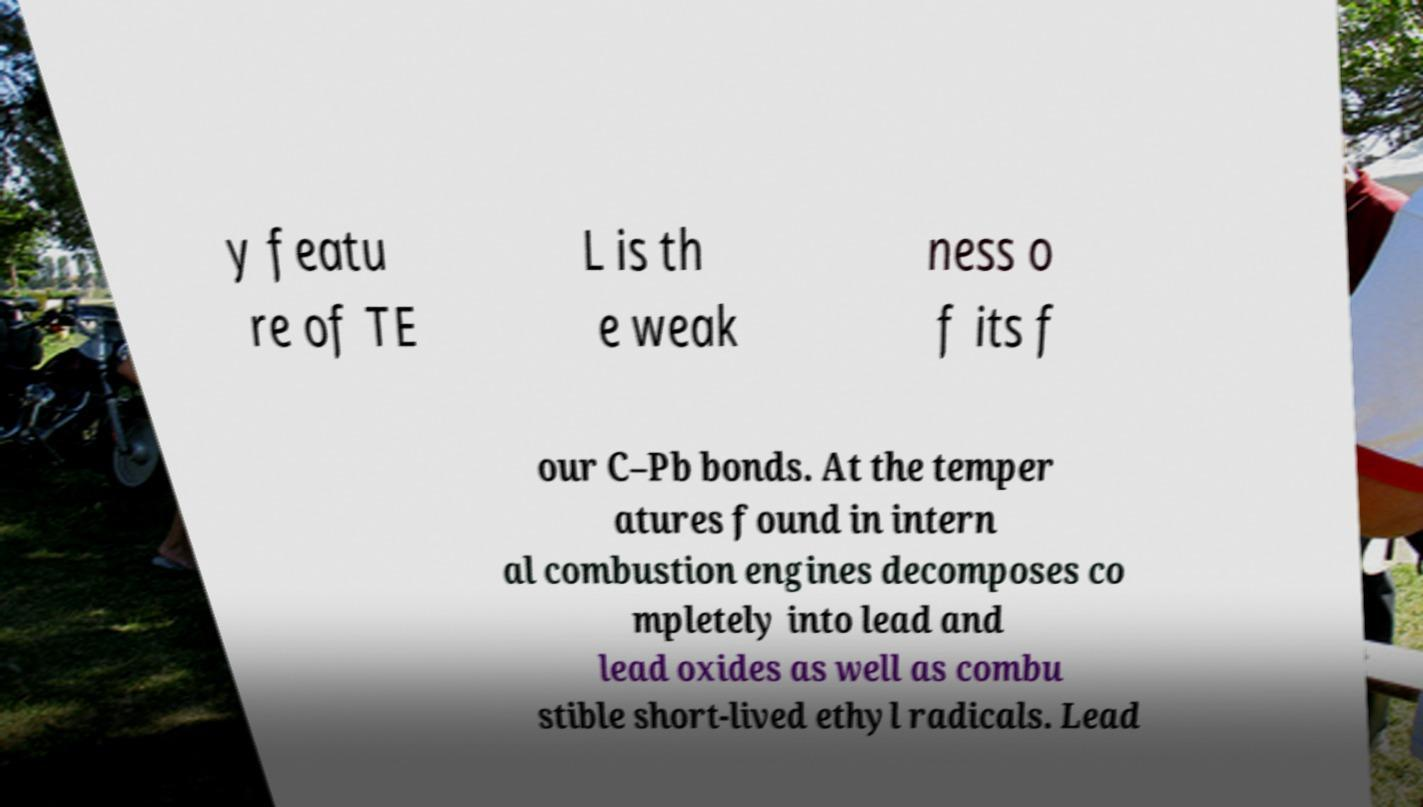Please read and relay the text visible in this image. What does it say? y featu re of TE L is th e weak ness o f its f our C–Pb bonds. At the temper atures found in intern al combustion engines decomposes co mpletely into lead and lead oxides as well as combu stible short-lived ethyl radicals. Lead 